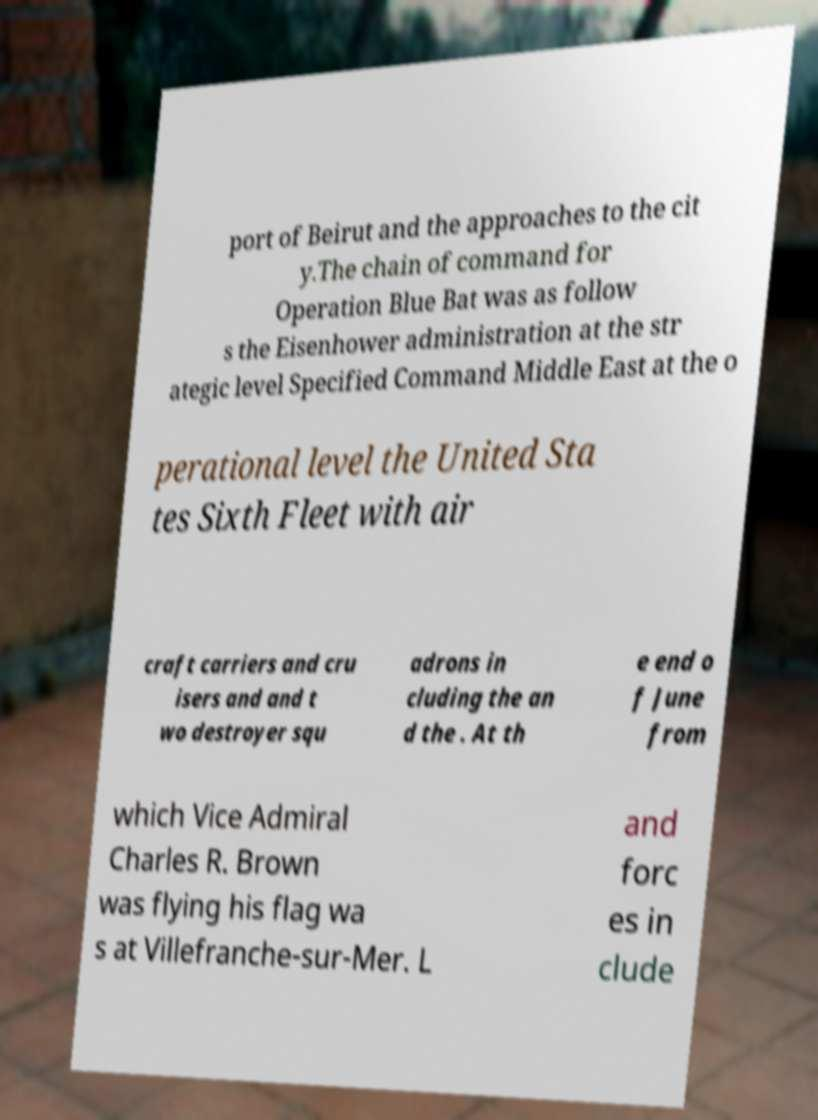I need the written content from this picture converted into text. Can you do that? port of Beirut and the approaches to the cit y.The chain of command for Operation Blue Bat was as follow s the Eisenhower administration at the str ategic level Specified Command Middle East at the o perational level the United Sta tes Sixth Fleet with air craft carriers and cru isers and and t wo destroyer squ adrons in cluding the an d the . At th e end o f June from which Vice Admiral Charles R. Brown was flying his flag wa s at Villefranche-sur-Mer. L and forc es in clude 